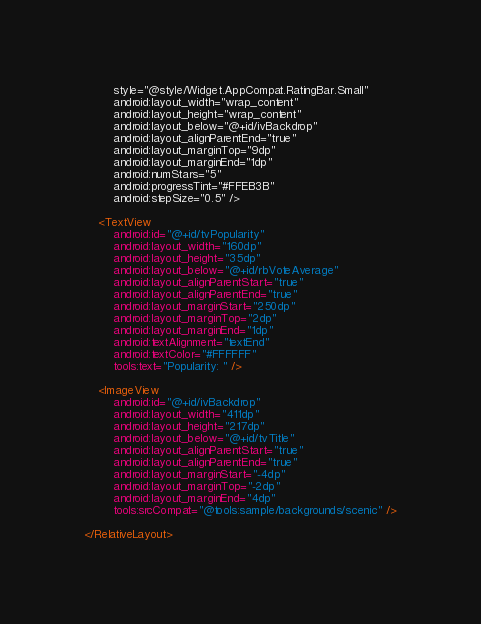Convert code to text. <code><loc_0><loc_0><loc_500><loc_500><_XML_>        style="@style/Widget.AppCompat.RatingBar.Small"
        android:layout_width="wrap_content"
        android:layout_height="wrap_content"
        android:layout_below="@+id/ivBackdrop"
        android:layout_alignParentEnd="true"
        android:layout_marginTop="9dp"
        android:layout_marginEnd="1dp"
        android:numStars="5"
        android:progressTint="#FFEB3B"
        android:stepSize="0.5" />

    <TextView
        android:id="@+id/tvPopularity"
        android:layout_width="160dp"
        android:layout_height="35dp"
        android:layout_below="@+id/rbVoteAverage"
        android:layout_alignParentStart="true"
        android:layout_alignParentEnd="true"
        android:layout_marginStart="250dp"
        android:layout_marginTop="2dp"
        android:layout_marginEnd="1dp"
        android:textAlignment="textEnd"
        android:textColor="#FFFFFF"
        tools:text="Popularity: " />

    <ImageView
        android:id="@+id/ivBackdrop"
        android:layout_width="411dp"
        android:layout_height="217dp"
        android:layout_below="@+id/tvTitle"
        android:layout_alignParentStart="true"
        android:layout_alignParentEnd="true"
        android:layout_marginStart="-4dp"
        android:layout_marginTop="-2dp"
        android:layout_marginEnd="4dp"
        tools:srcCompat="@tools:sample/backgrounds/scenic" />

</RelativeLayout></code> 